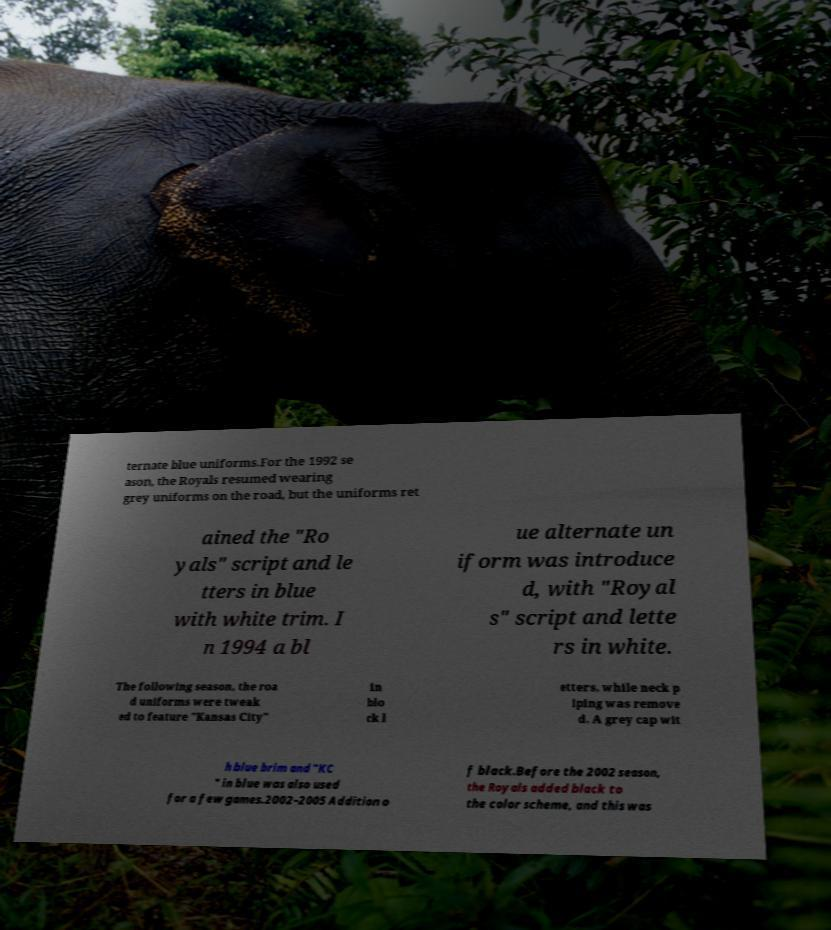I need the written content from this picture converted into text. Can you do that? ternate blue uniforms.For the 1992 se ason, the Royals resumed wearing grey uniforms on the road, but the uniforms ret ained the "Ro yals" script and le tters in blue with white trim. I n 1994 a bl ue alternate un iform was introduce d, with "Royal s" script and lette rs in white. The following season, the roa d uniforms were tweak ed to feature "Kansas City" in blo ck l etters, while neck p iping was remove d. A grey cap wit h blue brim and "KC " in blue was also used for a few games.2002–2005 Addition o f black.Before the 2002 season, the Royals added black to the color scheme, and this was 